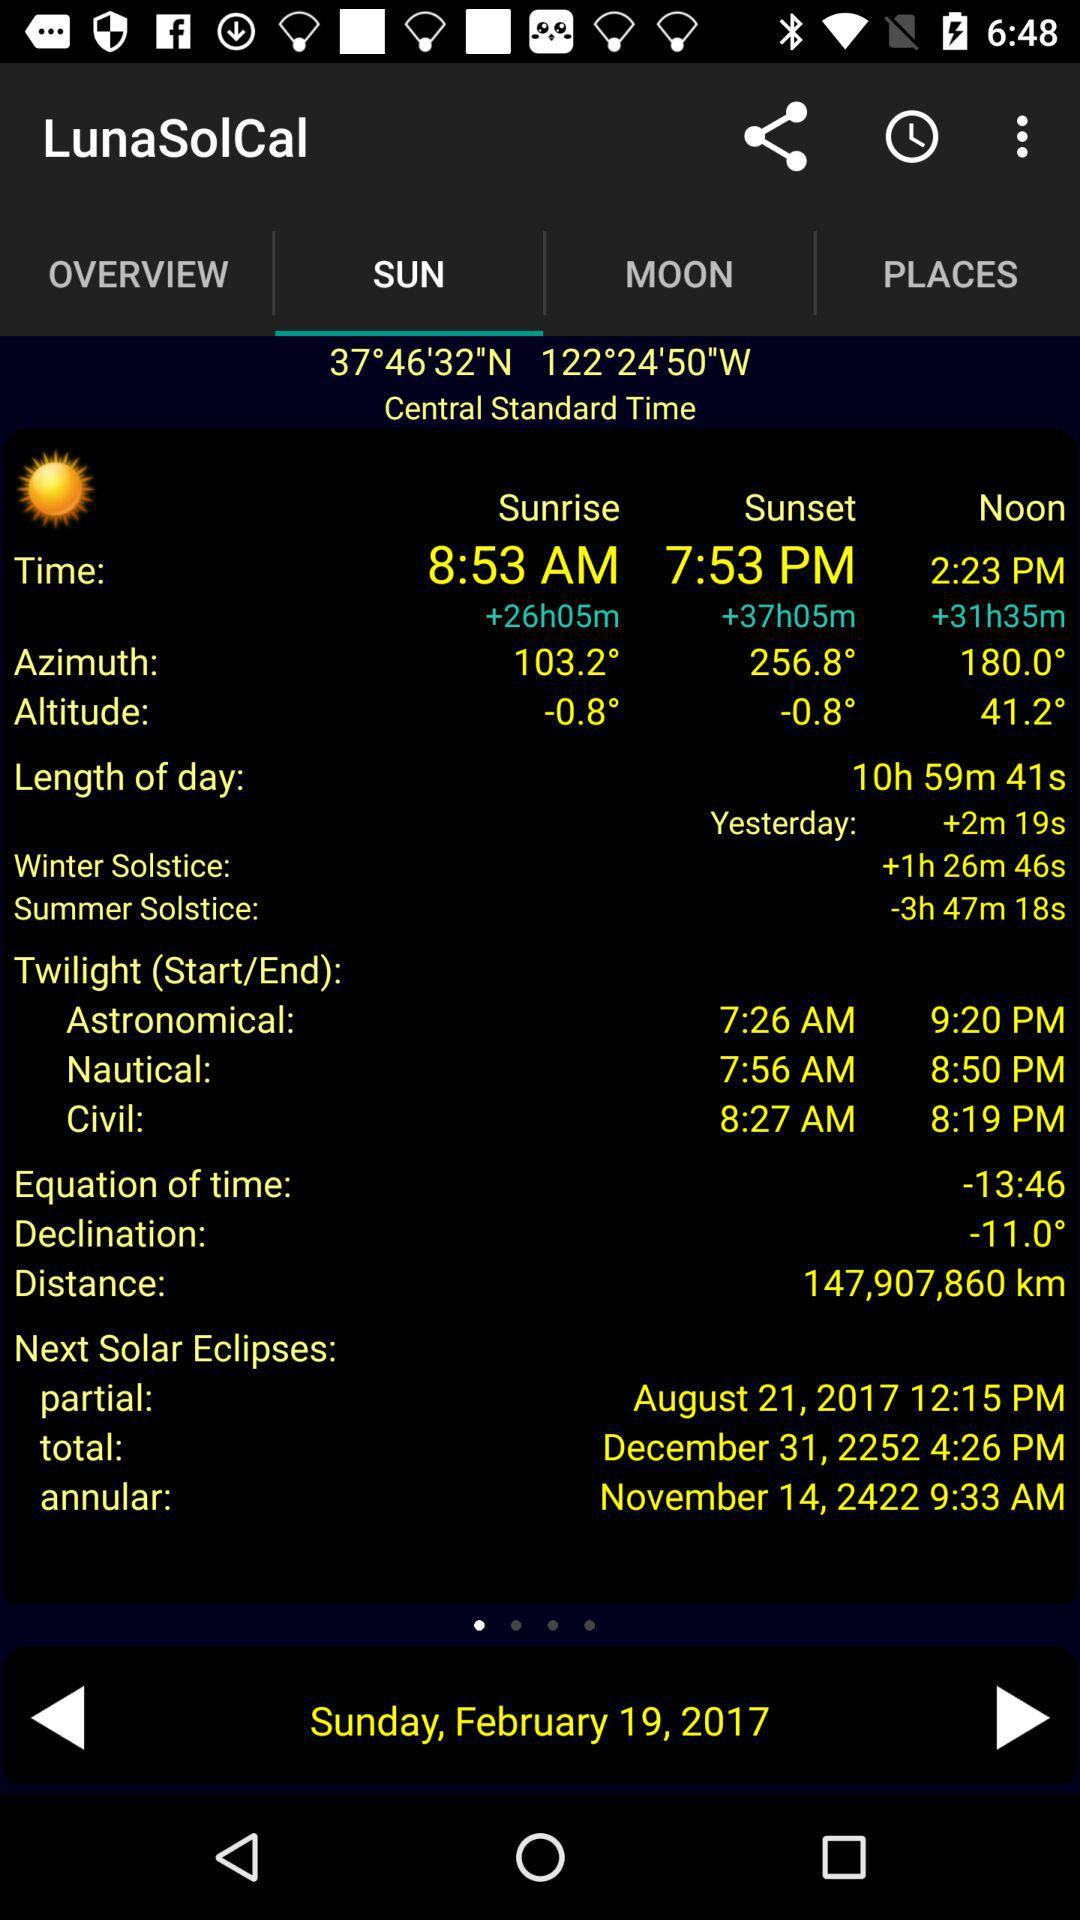What is the selected tab? The selected tab is "SUN". 